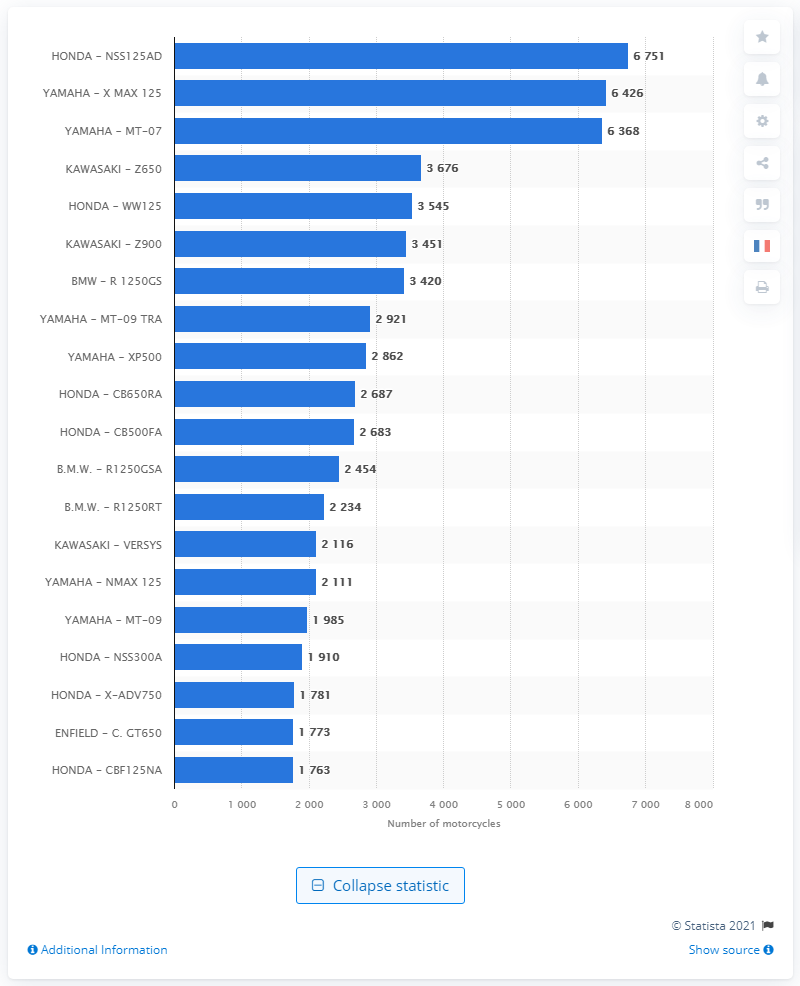Point out several critical features in this image. The Yamaha X MAX 125 was the most popular motorcycle on the French market in 2019. In 2019, the HONDA NSS125AD was the best-selling motorcycle in France. 